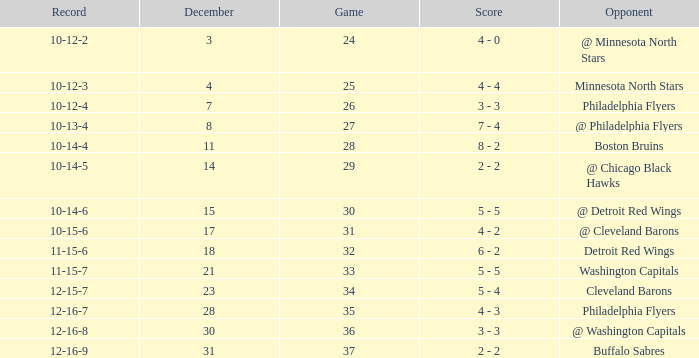What is the lowest December, when Score is "4 - 4"? 4.0. 